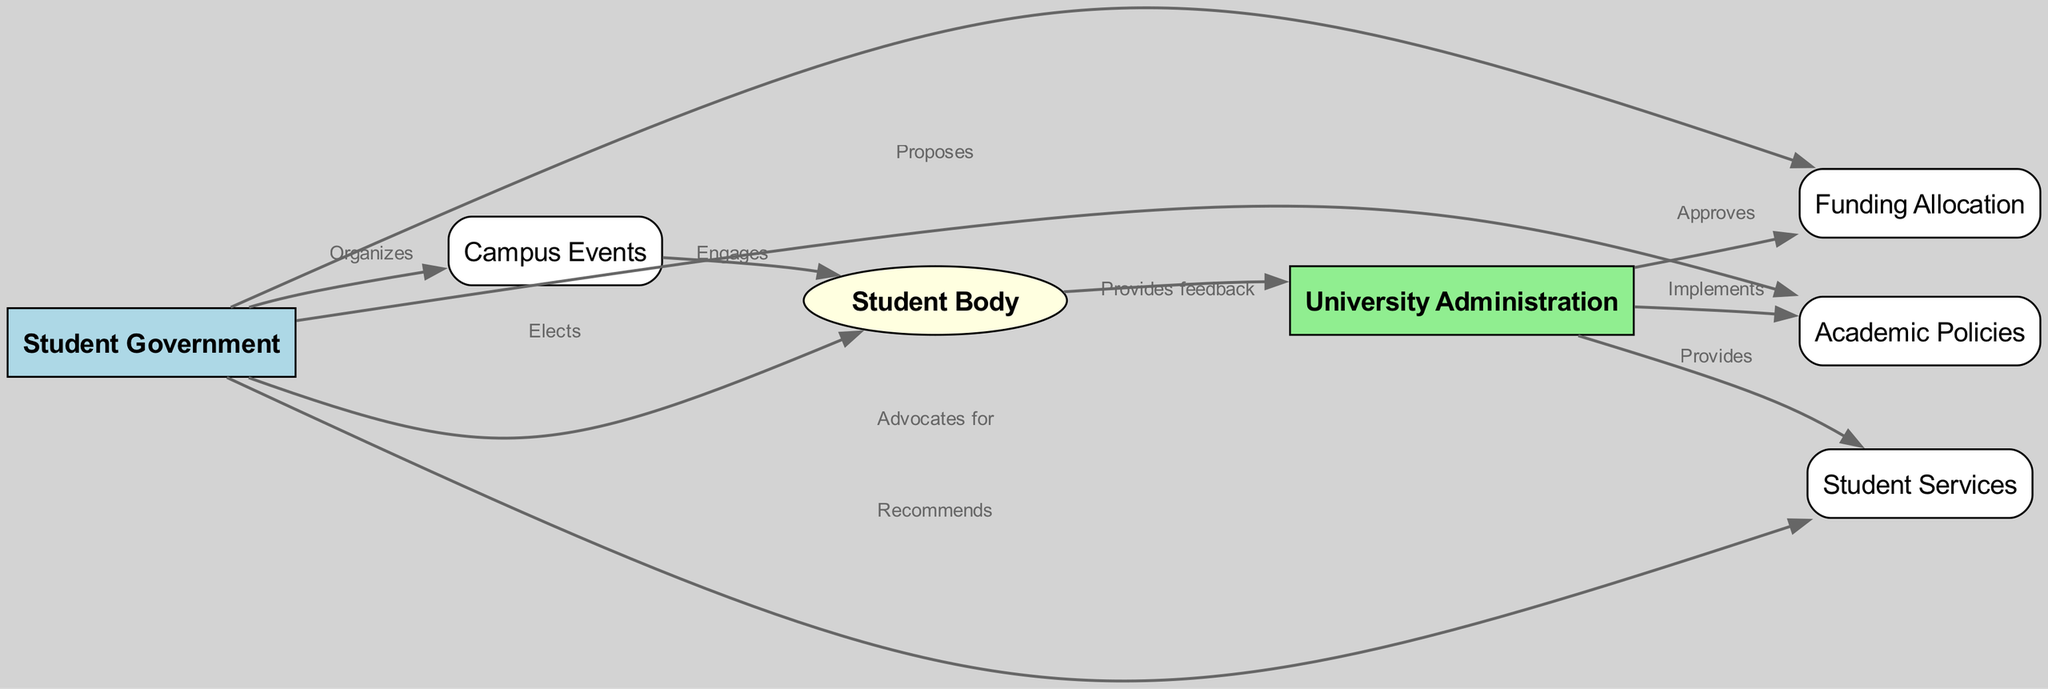What is the total number of nodes in the diagram? There are a total of seven nodes representing various entities related to the student government system, including Student Government, University Administration, Student Body, Funding Allocation, Campus Events, Academic Policies, and Student Services.
Answer: 7 Which node is responsible for organizing campus events? The diagram indicates that the Student Government node has a direct edge labeled "Organizes" pointing to the Campus Events node, indicating that it is responsible for this function.
Answer: Student Government What action does the University Administration take regarding funding? The University Administration node is connected to the Funding Allocation node via an edge labeled "Approves," indicating that its action is to approve funding.
Answer: Approves How does the Student Body provide feedback? The feedback provided by the Student Body is directed towards the University Administration as shown by the edge labeled "Provides feedback" linking these nodes, indicating that this is the pathway for such interaction.
Answer: Provides feedback What are the two main outputs of the Student Government node? The Student Government node has outgoing edges leading to Funding Allocation, Campus Events, Academic Policies, and Student Services, implying it also organizes events and advocates for policies, so the two main outputs are organizing campus events and advocating for academic policies.
Answer: Organizes campus events and advocates for academic policies Which node does the Student Body elect? According to the diagram, there is an edge from the Student Body to the Student Government labeled "Elects," which clarifies that the Student Body has the role of electing members of the Student Government.
Answer: Student Government What is the relationship between Campus Events and the Student Body? The diagram demonstrates a causal relationship through the edge labeled "Engages" between Campus Events and Student Body, suggesting that Campus Events significantly engage or involve the Student Body.
Answer: Engages How do academic policies get implemented? The relationship in the diagram shows that the University Administration implements academic policies as indicated by the edge that connects the University Administration to the Academic Policies node labeled "Implements."
Answer: Implements What does the Student Government recommend? The diagram indicates that the Student Government node is linked to the Student Services node with an edge labeled "Recommends," which shows that the Student Government's role includes making recommendations regarding student services.
Answer: Student Services 